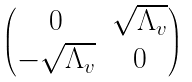Convert formula to latex. <formula><loc_0><loc_0><loc_500><loc_500>\begin{pmatrix} 0 & \sqrt { \Lambda _ { v } } \\ - \sqrt { \Lambda _ { v } } & 0 \end{pmatrix}</formula> 